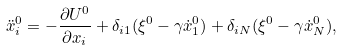Convert formula to latex. <formula><loc_0><loc_0><loc_500><loc_500>\ddot { x } _ { i } ^ { 0 } = - \frac { \partial U ^ { 0 } } { \partial x _ { i } } + \delta _ { i 1 } ( \xi ^ { 0 } - \gamma \dot { x } ^ { 0 } _ { 1 } ) + \delta _ { i N } ( \xi ^ { 0 } - \gamma \dot { x } ^ { 0 } _ { N } ) ,</formula> 